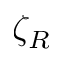<formula> <loc_0><loc_0><loc_500><loc_500>\zeta _ { R }</formula> 